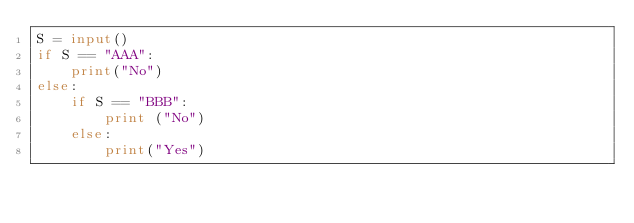<code> <loc_0><loc_0><loc_500><loc_500><_Python_>S = input()
if S == "AAA":
    print("No")
else:
    if S == "BBB":
        print ("No")
    else:
        print("Yes")</code> 